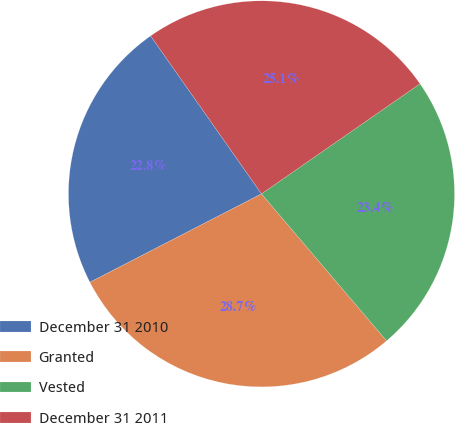<chart> <loc_0><loc_0><loc_500><loc_500><pie_chart><fcel>December 31 2010<fcel>Granted<fcel>Vested<fcel>December 31 2011<nl><fcel>22.83%<fcel>28.65%<fcel>23.44%<fcel>25.08%<nl></chart> 